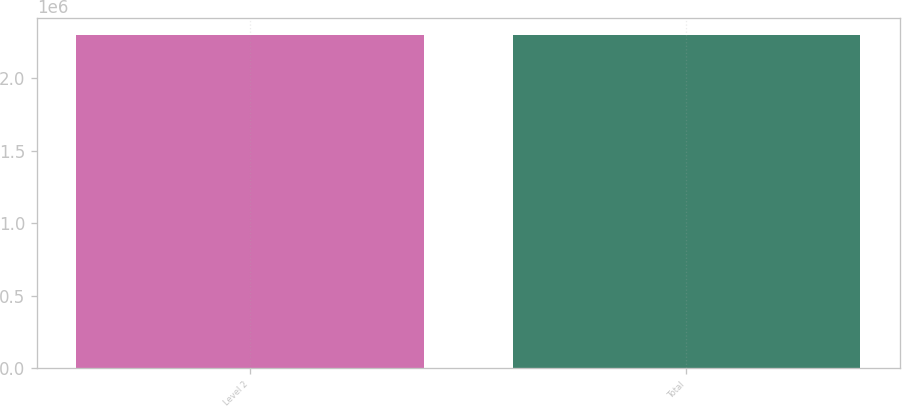<chart> <loc_0><loc_0><loc_500><loc_500><bar_chart><fcel>Level 2<fcel>Total<nl><fcel>2.29994e+06<fcel>2.29994e+06<nl></chart> 